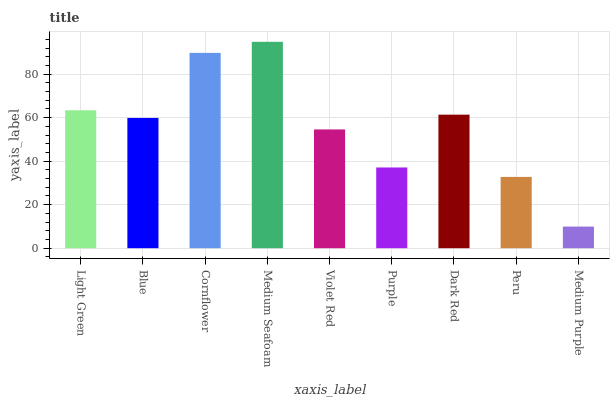Is Blue the minimum?
Answer yes or no. No. Is Blue the maximum?
Answer yes or no. No. Is Light Green greater than Blue?
Answer yes or no. Yes. Is Blue less than Light Green?
Answer yes or no. Yes. Is Blue greater than Light Green?
Answer yes or no. No. Is Light Green less than Blue?
Answer yes or no. No. Is Blue the high median?
Answer yes or no. Yes. Is Blue the low median?
Answer yes or no. Yes. Is Violet Red the high median?
Answer yes or no. No. Is Purple the low median?
Answer yes or no. No. 